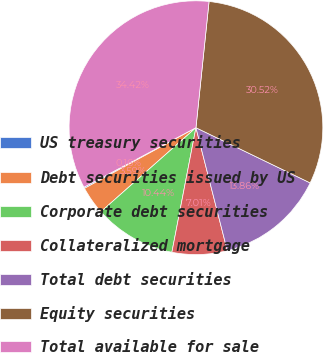Convert chart to OTSL. <chart><loc_0><loc_0><loc_500><loc_500><pie_chart><fcel>US treasury securities<fcel>Debt securities issued by US<fcel>Corporate debt securities<fcel>Collateralized mortgage<fcel>Total debt securities<fcel>Equity securities<fcel>Total available for sale<nl><fcel>0.16%<fcel>3.59%<fcel>10.44%<fcel>7.01%<fcel>13.86%<fcel>30.52%<fcel>34.42%<nl></chart> 